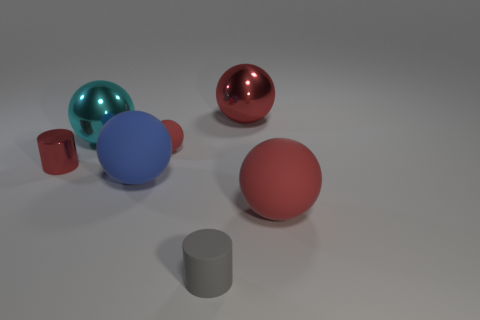How many red balls must be subtracted to get 1 red balls? 2 Subtract all brown cylinders. How many red spheres are left? 3 Subtract all tiny balls. How many balls are left? 4 Subtract all cyan spheres. How many spheres are left? 4 Subtract all brown spheres. Subtract all cyan blocks. How many spheres are left? 5 Add 2 tiny metal things. How many objects exist? 9 Subtract all cylinders. How many objects are left? 5 Subtract all small things. Subtract all small metallic cylinders. How many objects are left? 3 Add 5 tiny spheres. How many tiny spheres are left? 6 Add 3 big cyan metallic things. How many big cyan metallic things exist? 4 